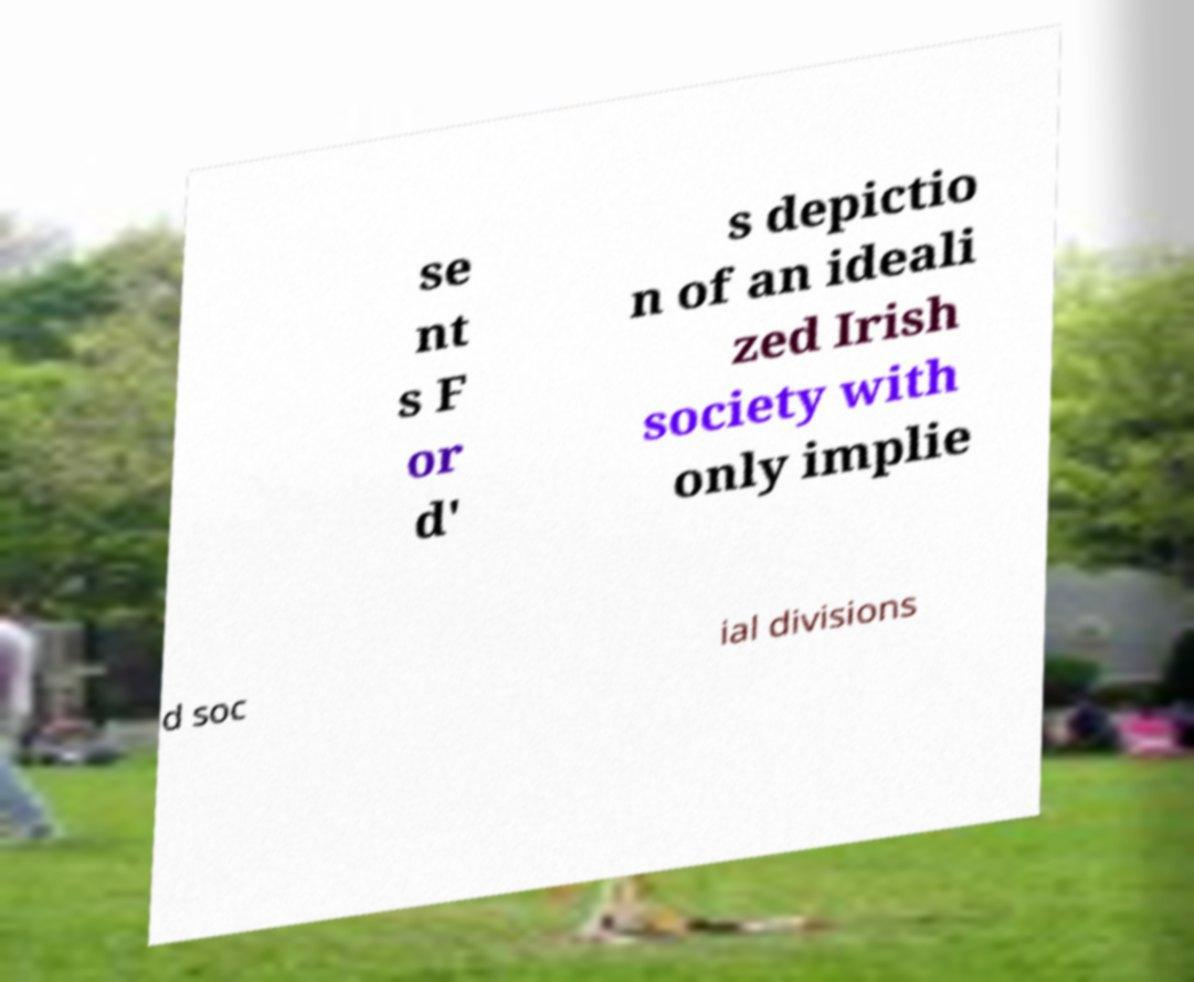Please read and relay the text visible in this image. What does it say? se nt s F or d' s depictio n of an ideali zed Irish society with only implie d soc ial divisions 